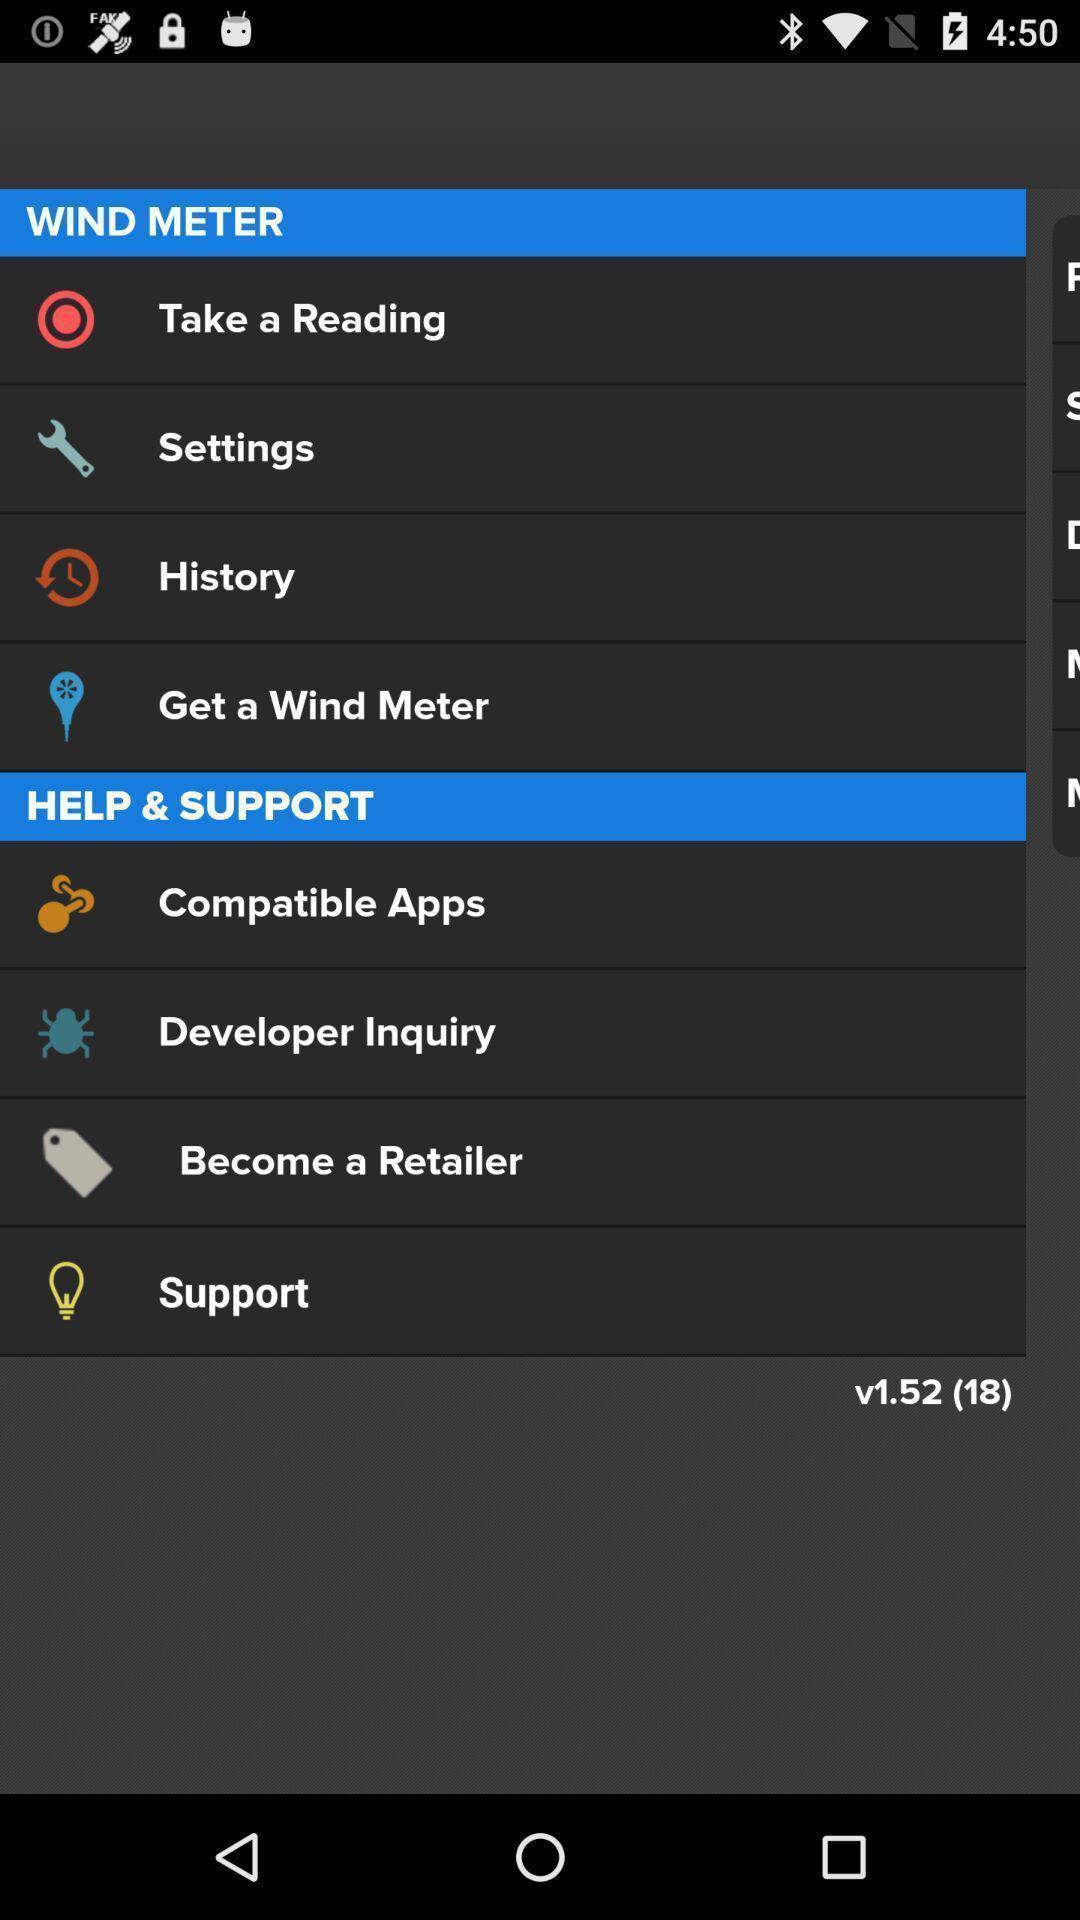What can you discern from this picture? Screen shows multiple options. 